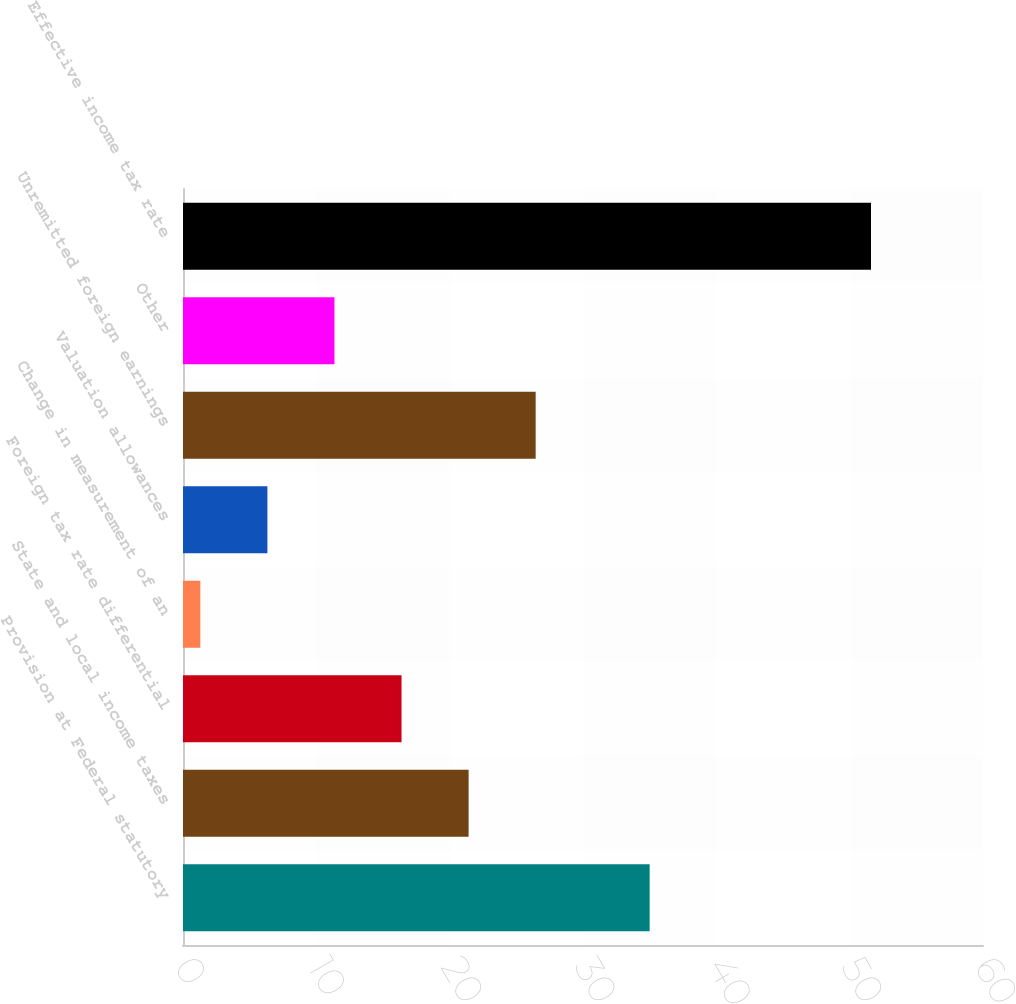Convert chart to OTSL. <chart><loc_0><loc_0><loc_500><loc_500><bar_chart><fcel>Provision at Federal statutory<fcel>State and local income taxes<fcel>Foreign tax rate differential<fcel>Change in measurement of an<fcel>Valuation allowances<fcel>Unremitted foreign earnings<fcel>Other<fcel>Effective income tax rate<nl><fcel>35<fcel>21.42<fcel>16.39<fcel>1.3<fcel>6.33<fcel>26.45<fcel>11.36<fcel>51.6<nl></chart> 